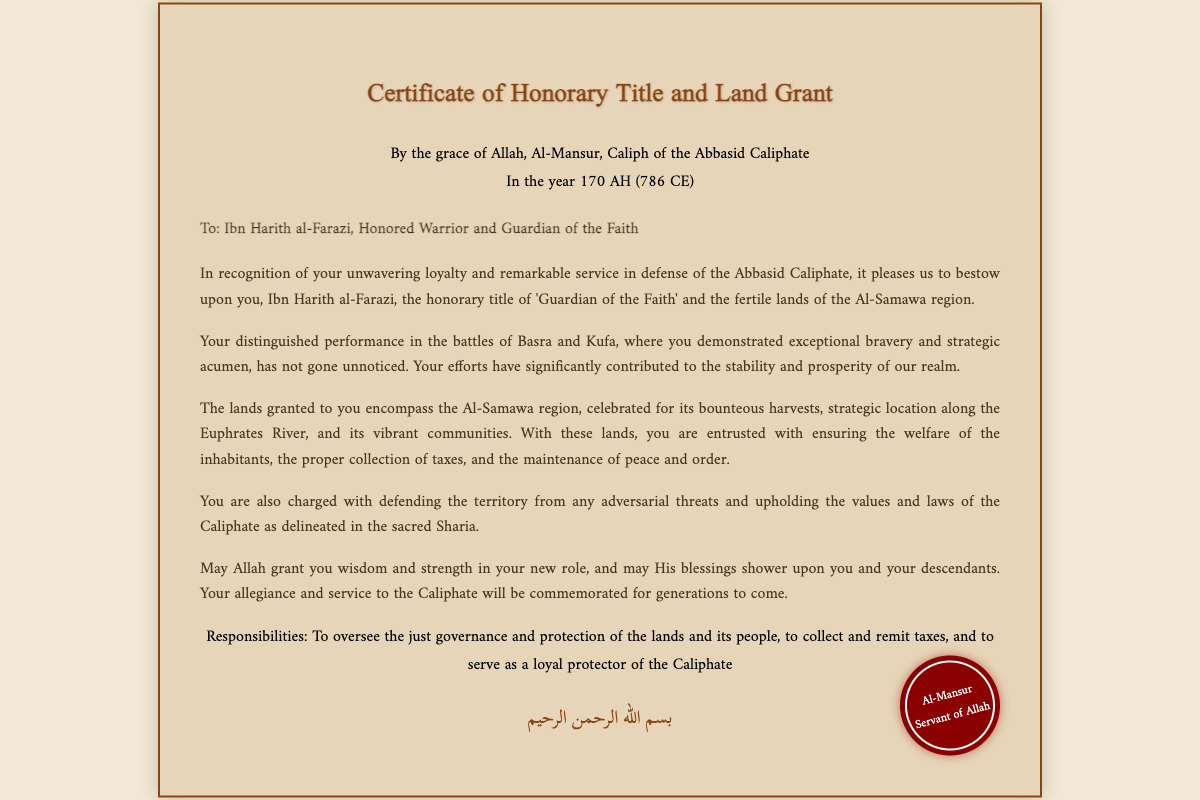What is the honorific title granted to Ibn Harith al-Farazi? The document states that Ibn Harith al-Farazi is bestowed with the honorary title of 'Guardian of the Faith'.
Answer: Guardian of the Faith Who is the Caliph mentioned in the certificate? The document indicates that the Caliph is Al-Mansur.
Answer: Al-Mansur What year is the certificate dated in the Islamic calendar? The document states that the certificate is dated in the year 170 AH.
Answer: 170 AH What region's lands are granted to Ibn Harith al-Farazi? The document specifies that the lands granted encompass the Al-Samawa region.
Answer: Al-Samawa What responsibilities are listed in the footer of the document? The document outlines the responsibilities as overseeing governance and protection, collecting taxes, and protecting the Caliphate.
Answer: Just governance and protection of the lands and its people What type of service did Ibn Harith al-Farazi provide to earn this title? The document mentions that he demonstrated unwavering loyalty and remarkable service in defense of the Abbasid Caliphate.
Answer: Unwavering loyalty and remarkable service Which two cities are mentioned in relation to Ibn Harith's battles? The document references Basra and Kufa in connection to his battles.
Answer: Basra and Kufa What divine guidance is mentioned at the beginning of the document? The document begins with "By the grace of Allah".
Answer: By the grace of Allah 